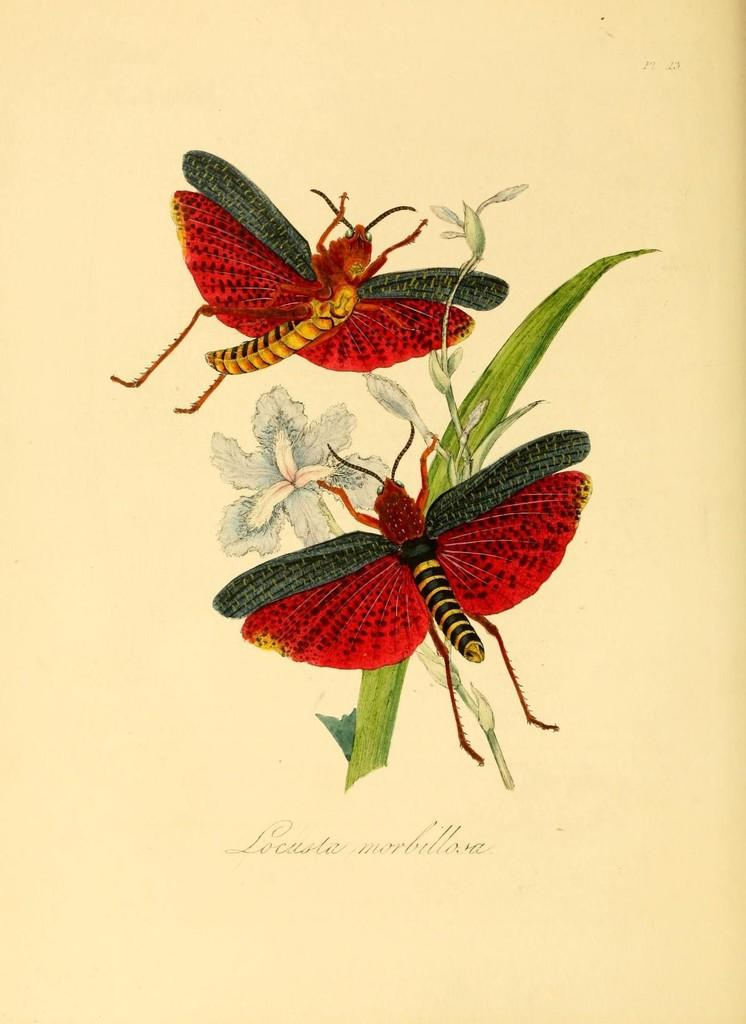What is the main subject of the image? The main subject of the image is an art of a butterfly or an insect. What is the insect doing in the image? The insect is depicted as sucking honey from flowers. What is the color of the background in the image? The background of the image is white in color. What might the white background be made of? The white background might be a paper. Can you tell me how many spiders are helping the insect in the image? There are no spiders present in the image, and the insect is not receiving help from any spiders. What type of cart is visible in the image? There is no cart present in the image. 